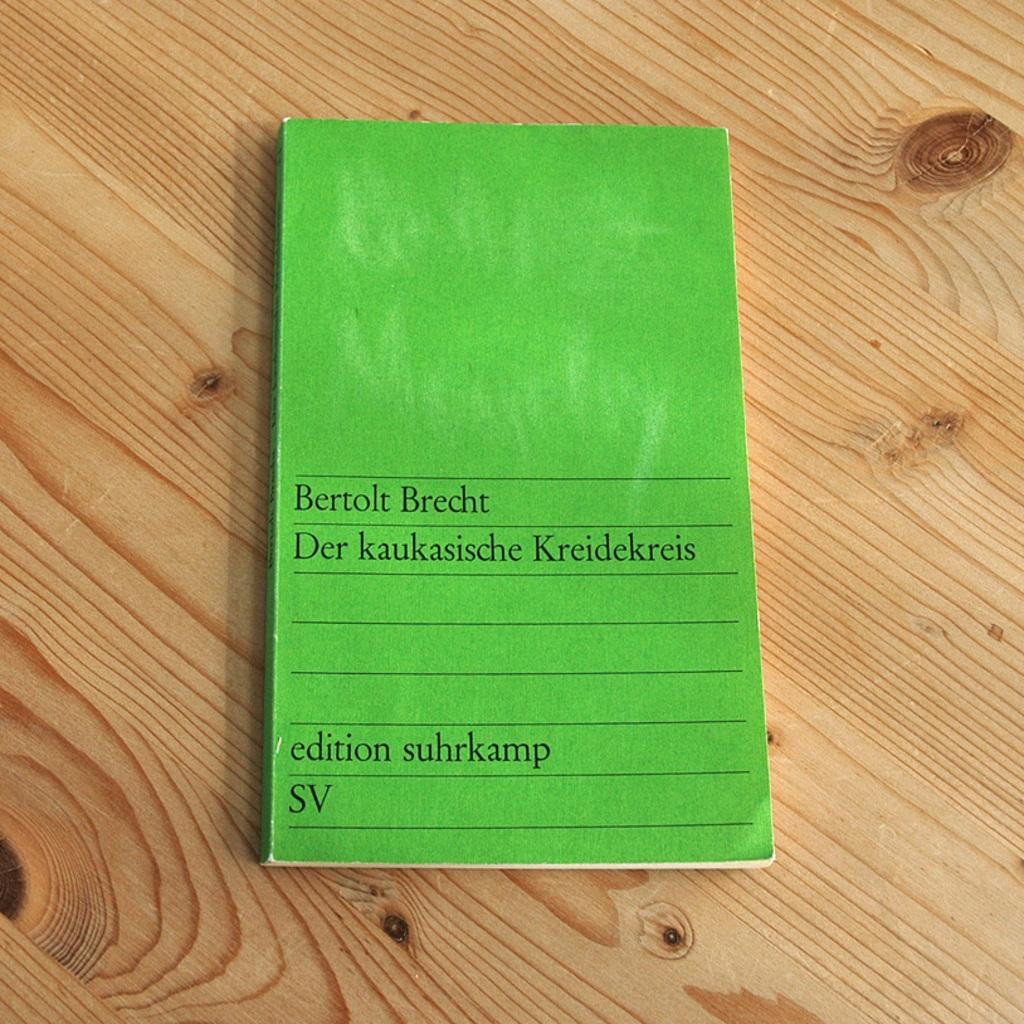<image>
Summarize the visual content of the image. A green pad of paper has SV on the bottom corner. 